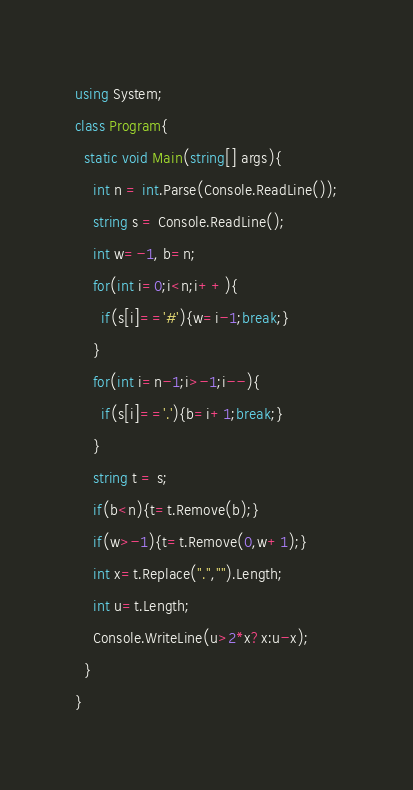<code> <loc_0><loc_0><loc_500><loc_500><_C#_>using System;
class Program{
  static void Main(string[] args){
    int n = int.Parse(Console.ReadLine());
    string s = Console.ReadLine();
    int w=-1, b=n;
    for(int i=0;i<n;i++){
      if(s[i]=='#'){w=i-1;break;}
    }
    for(int i=n-1;i>-1;i--){
      if(s[i]=='.'){b=i+1;break;}
    }
    string t = s;
    if(b<n){t=t.Remove(b);}
    if(w>-1){t=t.Remove(0,w+1);}
    int x=t.Replace(".","").Length;
    int u=t.Length;
    Console.WriteLine(u>2*x?x:u-x);
  }
}</code> 